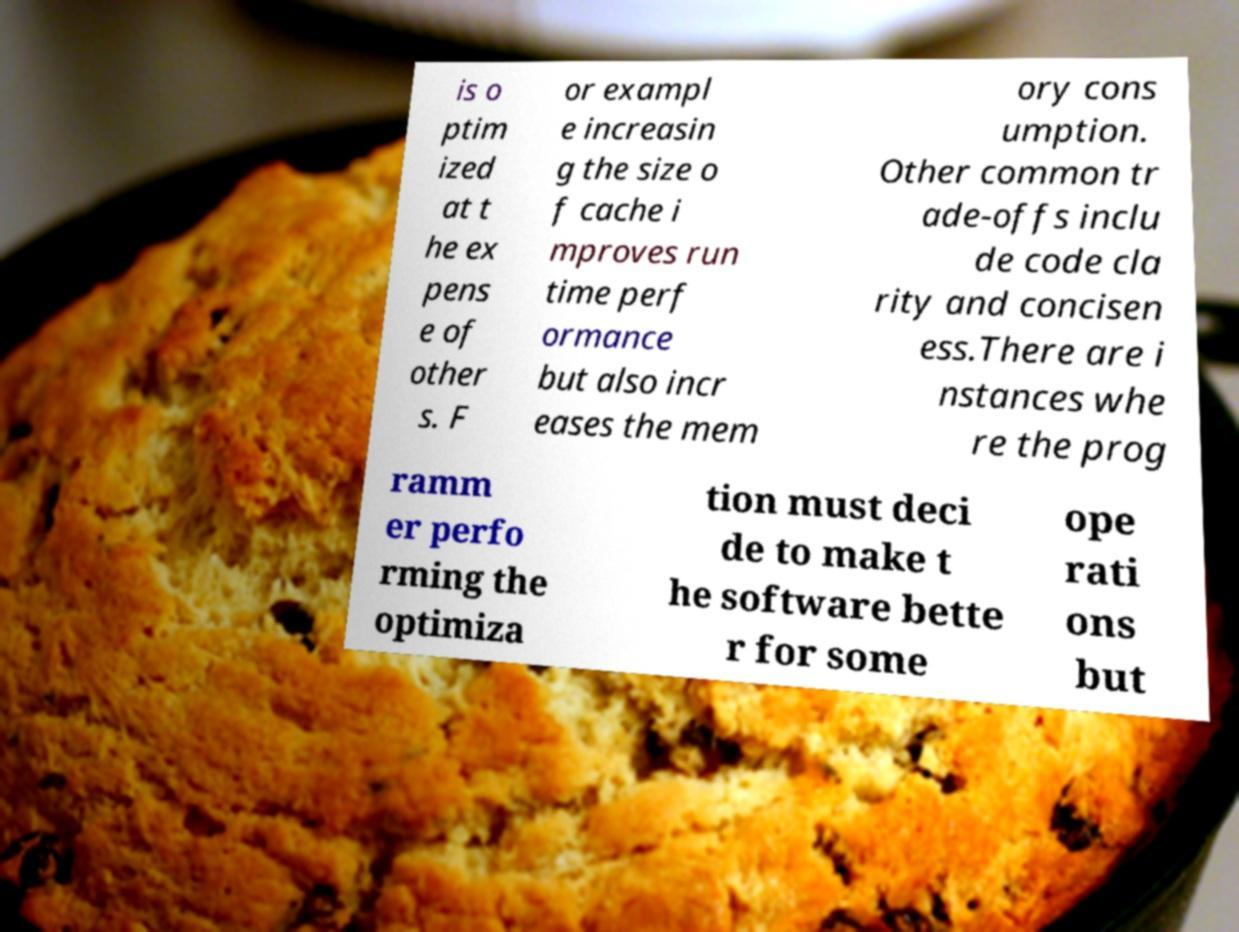Can you accurately transcribe the text from the provided image for me? is o ptim ized at t he ex pens e of other s. F or exampl e increasin g the size o f cache i mproves run time perf ormance but also incr eases the mem ory cons umption. Other common tr ade-offs inclu de code cla rity and concisen ess.There are i nstances whe re the prog ramm er perfo rming the optimiza tion must deci de to make t he software bette r for some ope rati ons but 